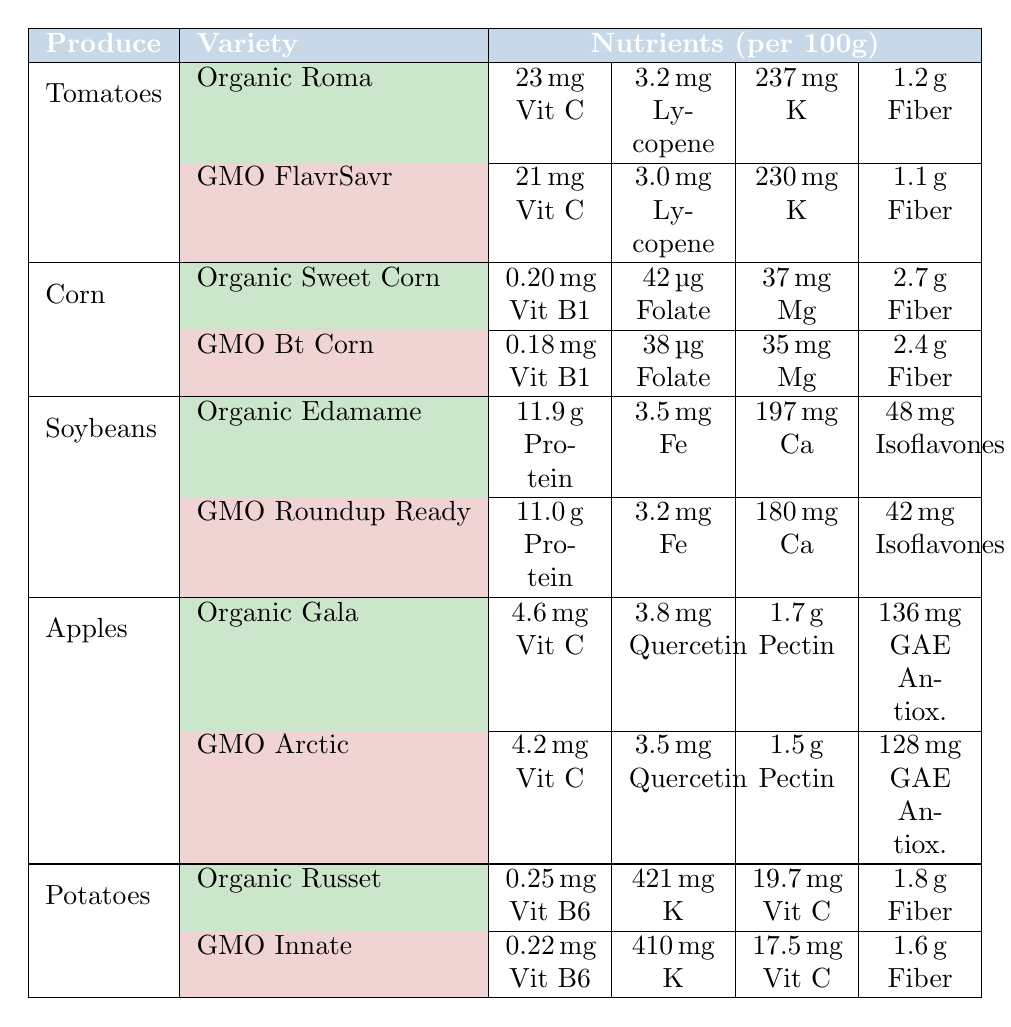What is the Vitamin C content in Organic Roma tomatoes? The table shows that Organic Roma tomatoes have a Vitamin C content of 23 mg per 100 grams.
Answer: 23 mg Which produce type has the highest Fiber content amongst the varieties listed? By comparing Fiber content across the table, Organic Sweet Corn has the highest Fiber content at 2.7 grams per 100 grams.
Answer: 2.7 grams Is the Potassium content higher in Organic Russet potatoes or GMO Innate potatoes? The table shows Organic Russet potatoes with 421 mg of Potassium, while GMO Innate potatoes have 410 mg. Therefore, Organic Russet has a higher Potassium content.
Answer: Yes How much more Protein does Organic Edamame have compared to GMO Roundup Ready soybeans? Organic Edamame has a Protein content of 11.9 grams and GMO Roundup Ready soybeans have 11.0 grams. The difference is 11.9 - 11.0 = 0.9 grams.
Answer: 0.9 grams What is the average Lycopene content in Tomatoes from both varieties? The Lycopene content for Organic Roma is 3.2 mg and for GMO FlavrSavr is 3.0 mg. The average is (3.2 + 3.0) / 2 = 3.1 mg.
Answer: 3.1 mg Which variety has more Antioxidants, Organic Gala apples or GMO Arctic apples? Organic Gala apples have 136 mg of antioxidants while GMO Arctic apples have 128 mg. Therefore, Organic Gala apples have more antioxidants.
Answer: Organic Gala Is the Folate content of Organic Sweet Corn greater than the Folate content of GMO Bt Corn? Organic Sweet Corn has 42 μg of Folate, while GMO Bt Corn has 38 μg. Organic Sweet Corn has a greater Folate content.
Answer: Yes What is the total amount of Fiber in Organic Sweet Corn and Organic Edamame combined? Organic Sweet Corn has 2.7 grams of Fiber and Organic Edamame has 1.2 grams. The total is 2.7 + 1.2 = 3.9 grams.
Answer: 3.9 grams How do the Vitamin B1 levels compare between Organic Sweet Corn and GMO Bt Corn? The table indicates that Organic Sweet Corn has 0.20 mg of Vitamin B1, whereas GMO Bt Corn has 0.18 mg. Organic Sweet Corn has a higher Vitamin B1 level.
Answer: Yes What nutrient in the GMO Roundup Ready soybean is lower than in the Organic Edamame? The Iron content in Organic Edamame is 3.5 mg, while in GMO Roundup Ready soybeans, it is 3.2 mg. Hence, Iron is lower in GMO Roundup Ready soybeans.
Answer: Iron What is the difference in Calcium content between Organic Edamame and GMO Roundup Ready soybeans? Organic Edamame contains 197 mg of Calcium, while GMO Roundup Ready has 180 mg. The difference is 197 - 180 = 17 mg.
Answer: 17 mg 